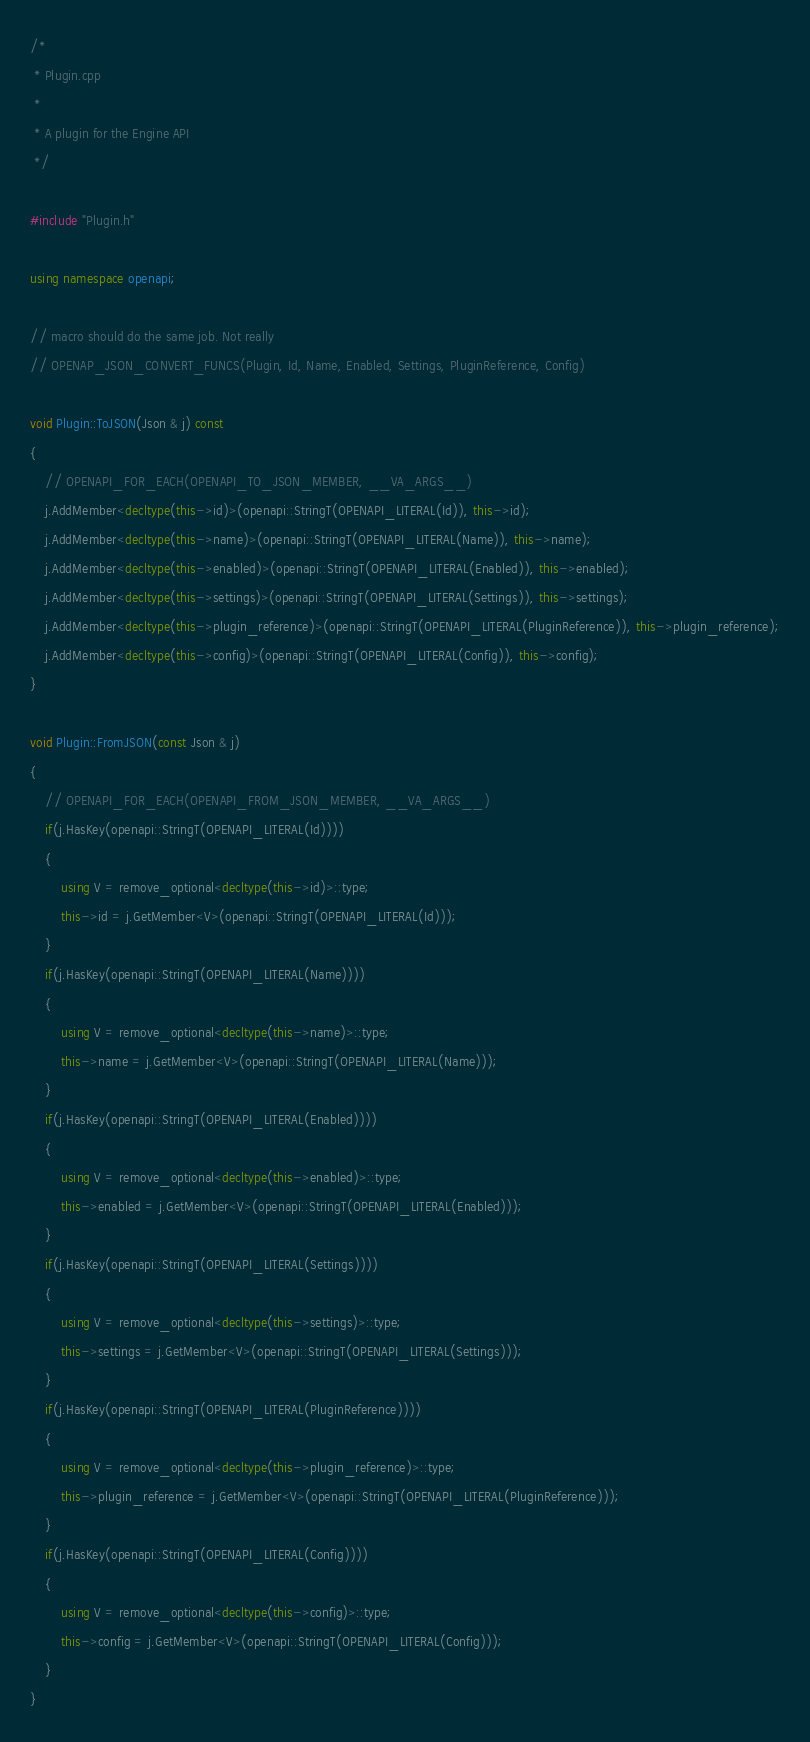Convert code to text. <code><loc_0><loc_0><loc_500><loc_500><_C++_>/*
 * Plugin.cpp
 *
 * A plugin for the Engine API
 */

#include "Plugin.h"

using namespace openapi;

// macro should do the same job. Not really
// OPENAP_JSON_CONVERT_FUNCS(Plugin, Id, Name, Enabled, Settings, PluginReference, Config)

void Plugin::ToJSON(Json & j) const
{
    // OPENAPI_FOR_EACH(OPENAPI_TO_JSON_MEMBER, __VA_ARGS__)
    j.AddMember<decltype(this->id)>(openapi::StringT(OPENAPI_LITERAL(Id)), this->id);
    j.AddMember<decltype(this->name)>(openapi::StringT(OPENAPI_LITERAL(Name)), this->name);
    j.AddMember<decltype(this->enabled)>(openapi::StringT(OPENAPI_LITERAL(Enabled)), this->enabled);
    j.AddMember<decltype(this->settings)>(openapi::StringT(OPENAPI_LITERAL(Settings)), this->settings);
    j.AddMember<decltype(this->plugin_reference)>(openapi::StringT(OPENAPI_LITERAL(PluginReference)), this->plugin_reference);
    j.AddMember<decltype(this->config)>(openapi::StringT(OPENAPI_LITERAL(Config)), this->config);
}

void Plugin::FromJSON(const Json & j)
{
    // OPENAPI_FOR_EACH(OPENAPI_FROM_JSON_MEMBER, __VA_ARGS__)
    if(j.HasKey(openapi::StringT(OPENAPI_LITERAL(Id))))
    {
        using V = remove_optional<decltype(this->id)>::type;
        this->id = j.GetMember<V>(openapi::StringT(OPENAPI_LITERAL(Id)));
    }
    if(j.HasKey(openapi::StringT(OPENAPI_LITERAL(Name))))
    {
        using V = remove_optional<decltype(this->name)>::type;
        this->name = j.GetMember<V>(openapi::StringT(OPENAPI_LITERAL(Name)));
    }
    if(j.HasKey(openapi::StringT(OPENAPI_LITERAL(Enabled))))
    {
        using V = remove_optional<decltype(this->enabled)>::type;
        this->enabled = j.GetMember<V>(openapi::StringT(OPENAPI_LITERAL(Enabled)));
    }
    if(j.HasKey(openapi::StringT(OPENAPI_LITERAL(Settings))))
    {
        using V = remove_optional<decltype(this->settings)>::type;
        this->settings = j.GetMember<V>(openapi::StringT(OPENAPI_LITERAL(Settings)));
    }
    if(j.HasKey(openapi::StringT(OPENAPI_LITERAL(PluginReference))))
    {
        using V = remove_optional<decltype(this->plugin_reference)>::type;
        this->plugin_reference = j.GetMember<V>(openapi::StringT(OPENAPI_LITERAL(PluginReference)));
    }
    if(j.HasKey(openapi::StringT(OPENAPI_LITERAL(Config))))
    {
        using V = remove_optional<decltype(this->config)>::type;
        this->config = j.GetMember<V>(openapi::StringT(OPENAPI_LITERAL(Config)));
    }
}

</code> 